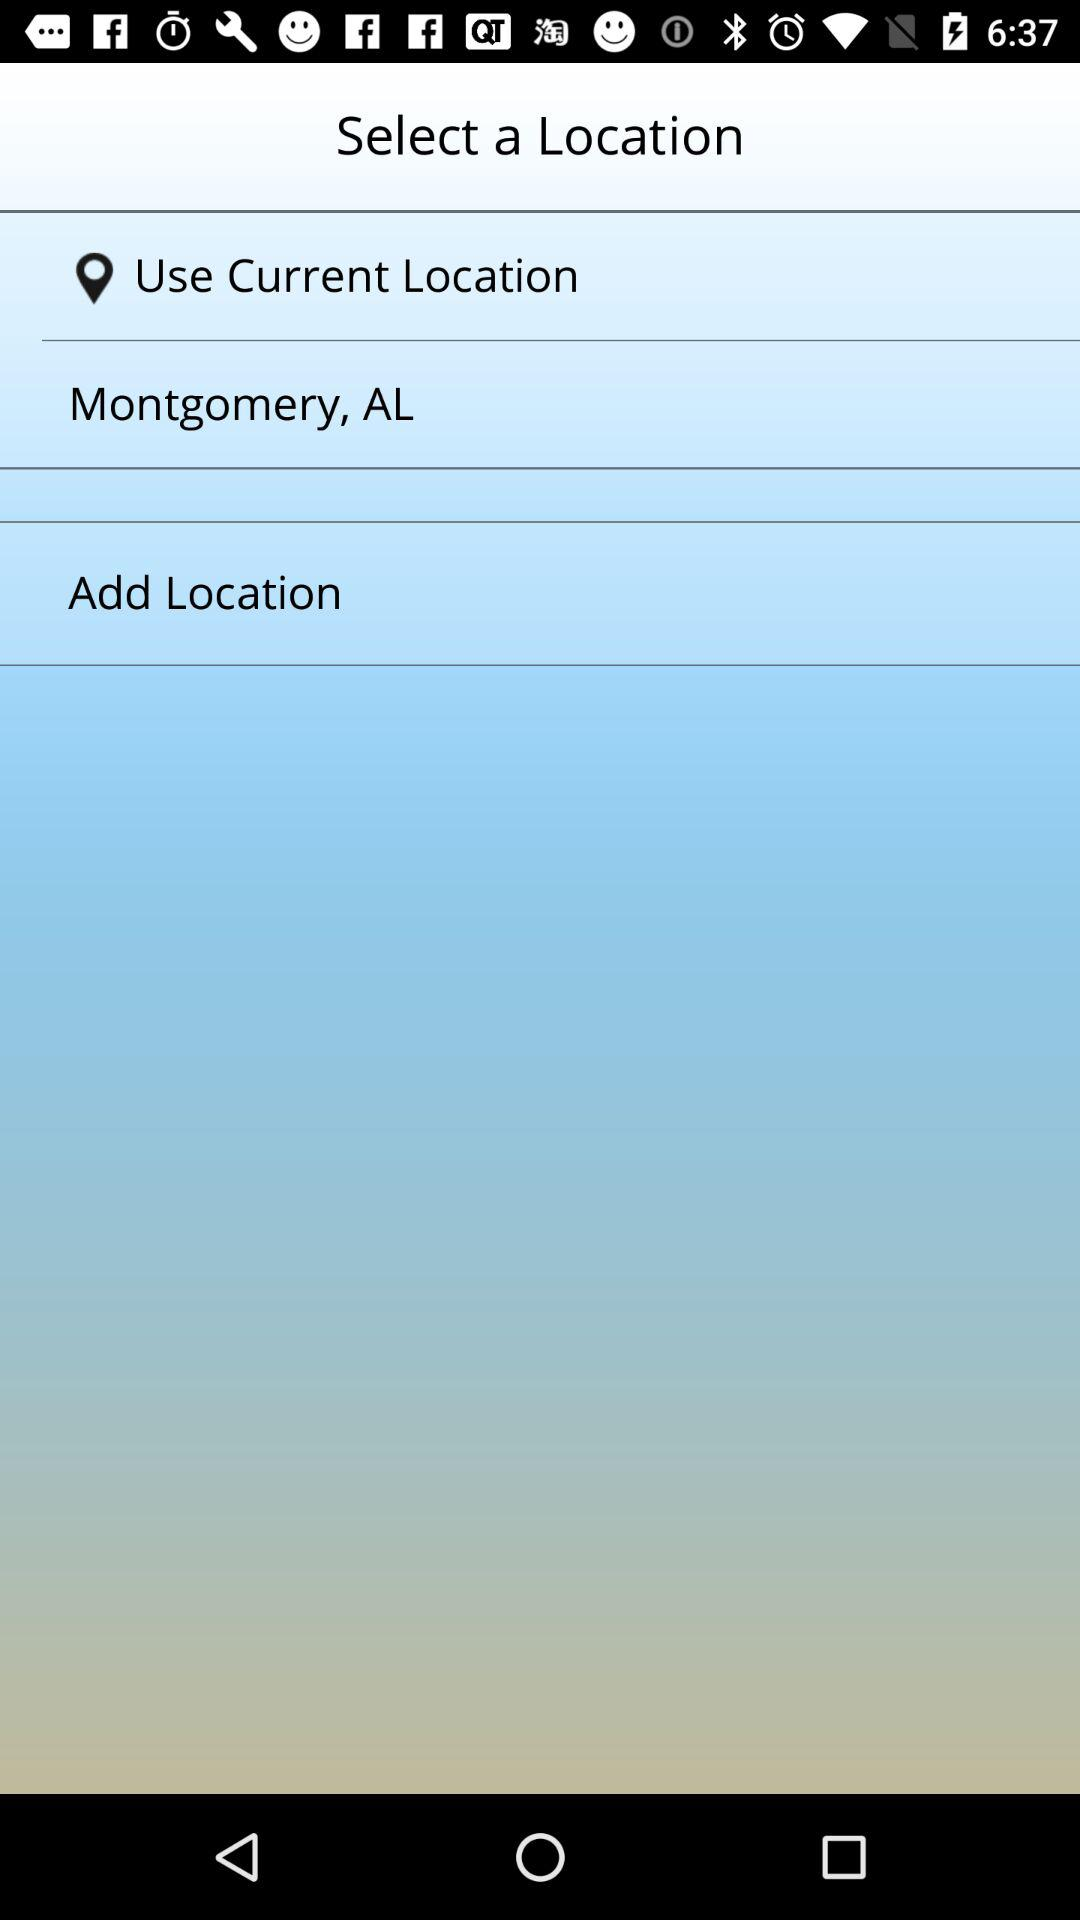What is the current location? The current location is Montgomery, AL. 